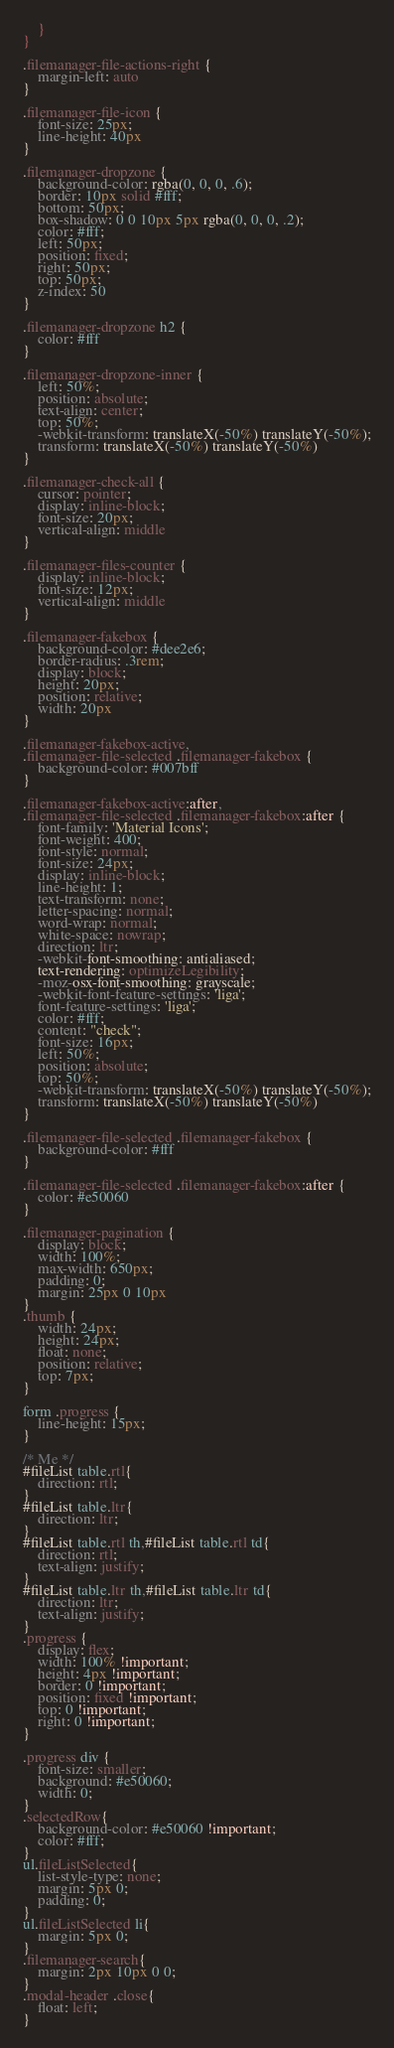<code> <loc_0><loc_0><loc_500><loc_500><_CSS_>    }
}

.filemanager-file-actions-right {
    margin-left: auto
}

.filemanager-file-icon {
    font-size: 25px;
    line-height: 40px
}

.filemanager-dropzone {
    background-color: rgba(0, 0, 0, .6);
    border: 10px solid #fff;
    bottom: 50px;
    box-shadow: 0 0 10px 5px rgba(0, 0, 0, .2);
    color: #fff;
    left: 50px;
    position: fixed;
    right: 50px;
    top: 50px;
    z-index: 50
}

.filemanager-dropzone h2 {
    color: #fff
}

.filemanager-dropzone-inner {
    left: 50%;
    position: absolute;
    text-align: center;
    top: 50%;
    -webkit-transform: translateX(-50%) translateY(-50%);
    transform: translateX(-50%) translateY(-50%)
}

.filemanager-check-all {
    cursor: pointer;
    display: inline-block;
    font-size: 20px;
    vertical-align: middle
}

.filemanager-files-counter {
    display: inline-block;
    font-size: 12px;
    vertical-align: middle
}

.filemanager-fakebox {
    background-color: #dee2e6;
    border-radius: .3rem;
    display: block;
    height: 20px;
    position: relative;
    width: 20px
}

.filemanager-fakebox-active,
.filemanager-file-selected .filemanager-fakebox {
    background-color: #007bff
}

.filemanager-fakebox-active:after,
.filemanager-file-selected .filemanager-fakebox:after {
    font-family: 'Material Icons';
    font-weight: 400;
    font-style: normal;
    font-size: 24px;
    display: inline-block;
    line-height: 1;
    text-transform: none;
    letter-spacing: normal;
    word-wrap: normal;
    white-space: nowrap;
    direction: ltr;
    -webkit-font-smoothing: antialiased;
    text-rendering: optimizeLegibility;
    -moz-osx-font-smoothing: grayscale;
    -webkit-font-feature-settings: 'liga';
    font-feature-settings: 'liga';
    color: #fff;
    content: "check";
    font-size: 16px;
    left: 50%;
    position: absolute;
    top: 50%;
    -webkit-transform: translateX(-50%) translateY(-50%);
    transform: translateX(-50%) translateY(-50%)
}

.filemanager-file-selected .filemanager-fakebox {
    background-color: #fff
}

.filemanager-file-selected .filemanager-fakebox:after {
    color: #e50060
}

.filemanager-pagination {
    display: block;
    width: 100%;
    max-width: 650px;
    padding: 0;
    margin: 25px 0 10px
}
.thumb {
    width: 24px;
    height: 24px;
    float: none;
    position: relative;
    top: 7px;
}

form .progress {
    line-height: 15px;
}

/* Me */
#fileList table.rtl{
    direction: rtl;
}
#fileList table.ltr{
    direction: ltr;
}
#fileList table.rtl th,#fileList table.rtl td{
    direction: rtl;
    text-align: justify;
}
#fileList table.ltr th,#fileList table.ltr td{
    direction: ltr;
    text-align: justify;
}
.progress {
    display: flex;
    width: 100% !important;
    height: 4px !important;
    border: 0 !important;
    position: fixed !important;
    top: 0 !important;
    right: 0 !important;
}

.progress div {
    font-size: smaller;
    background: #e50060;
    width: 0;
}
.selectedRow{
    background-color: #e50060 !important;
    color: #fff;
}
ul.fileListSelected{
    list-style-type: none;
    margin: 5px 0;
    padding: 0;
}
ul.fileListSelected li{
    margin: 5px 0;
}
.filemanager-search{
    margin: 2px 10px 0 0;
}
.modal-header .close{
    float: left;
}</code> 